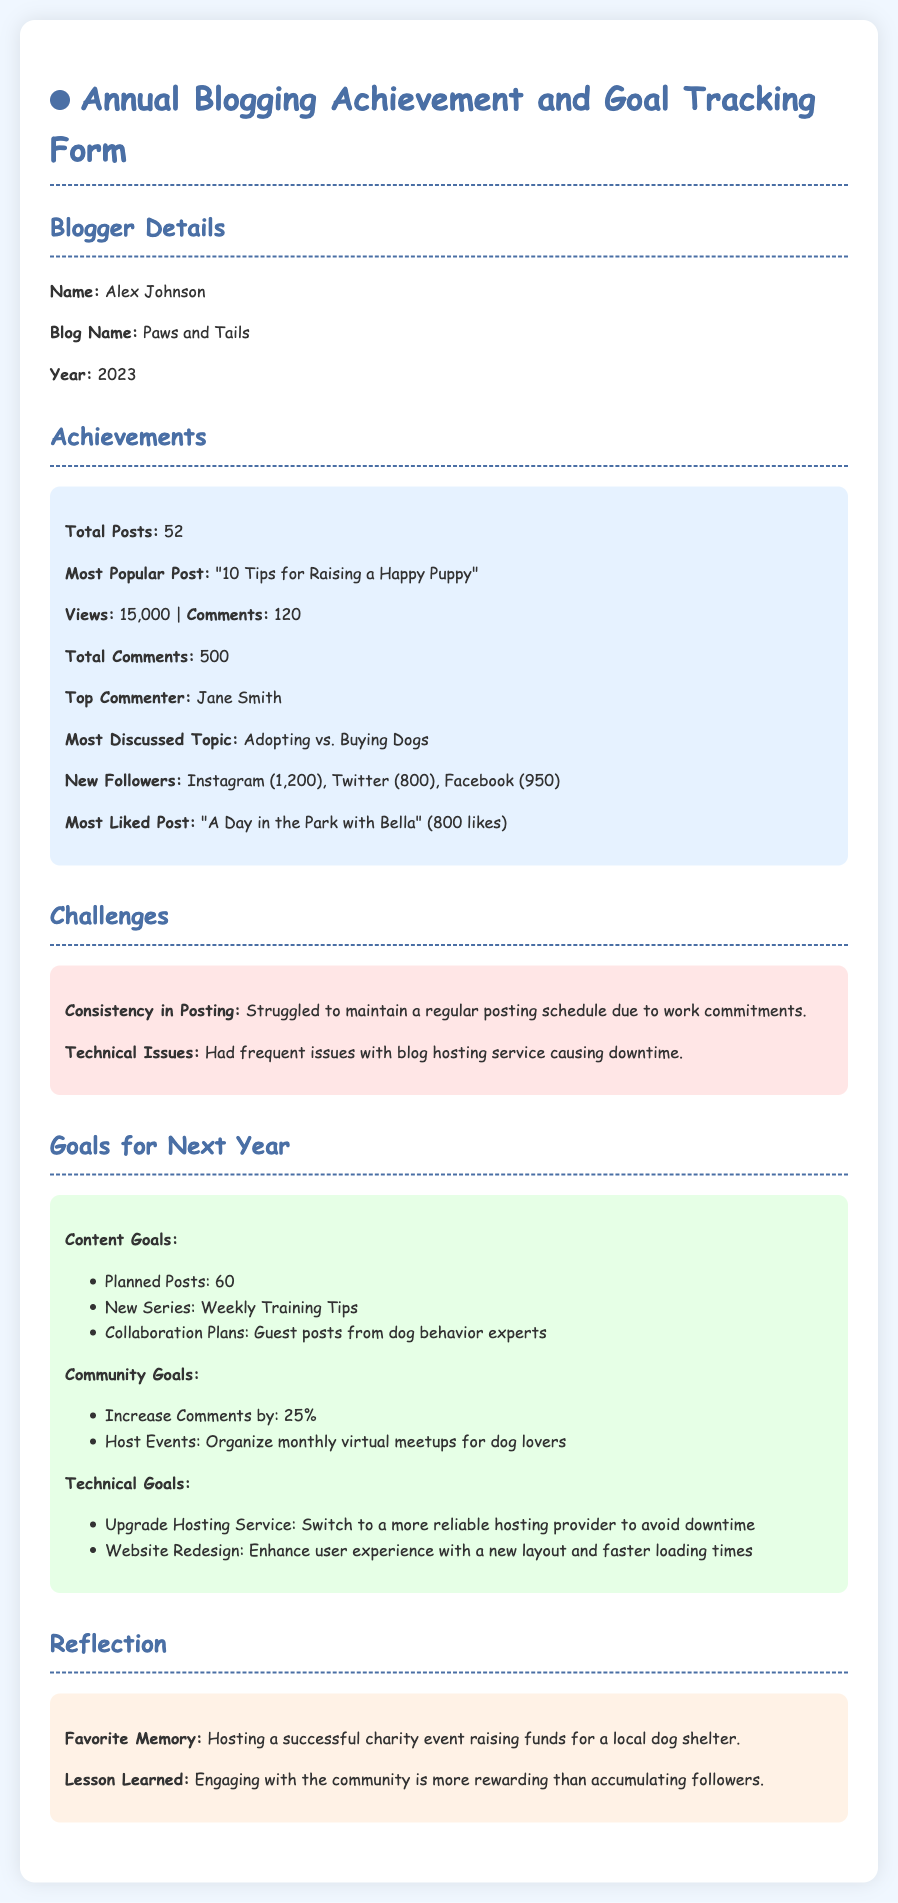What is the name of the blogger? The name of the blogger is provided under the "Blogger Details" section of the document.
Answer: Alex Johnson What is the blog name? The blog name is explicitly stated in the "Blogger Details" section.
Answer: Paws and Tails How many total posts were made in 2023? The total posts made is specified in the "Achievements" section of the document.
Answer: 52 What was the most popular post? This information is listed under the "Achievements" section of the document.
Answer: "10 Tips for Raising a Happy Puppy" What percentage increase in comments is targeted for next year? The target for increasing comments is stated in the "Community Goals" section as a percentage.
Answer: 25% What is one of the technical goals for next year? This is outlined under the "Technical Goals" section, where specific improvements are mentioned.
Answer: Upgrade Hosting Service What is a favorite memory mentioned? The favorite memory is described in the "Reflection" section of the document.
Answer: Hosting a successful charity event raising funds for a local dog shelter What lesson was learned this year? The lesson learned is detailed in the "Reflection" section, reflecting on community engagement.
Answer: Engaging with the community is more rewarding than accumulating followers What was the most discussed topic in 2023? The most discussed topic is highlighted in the "Achievements" section of the document.
Answer: Adopting vs. Buying Dogs 